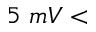Convert formula to latex. <formula><loc_0><loc_0><loc_500><loc_500>5 m V <</formula> 